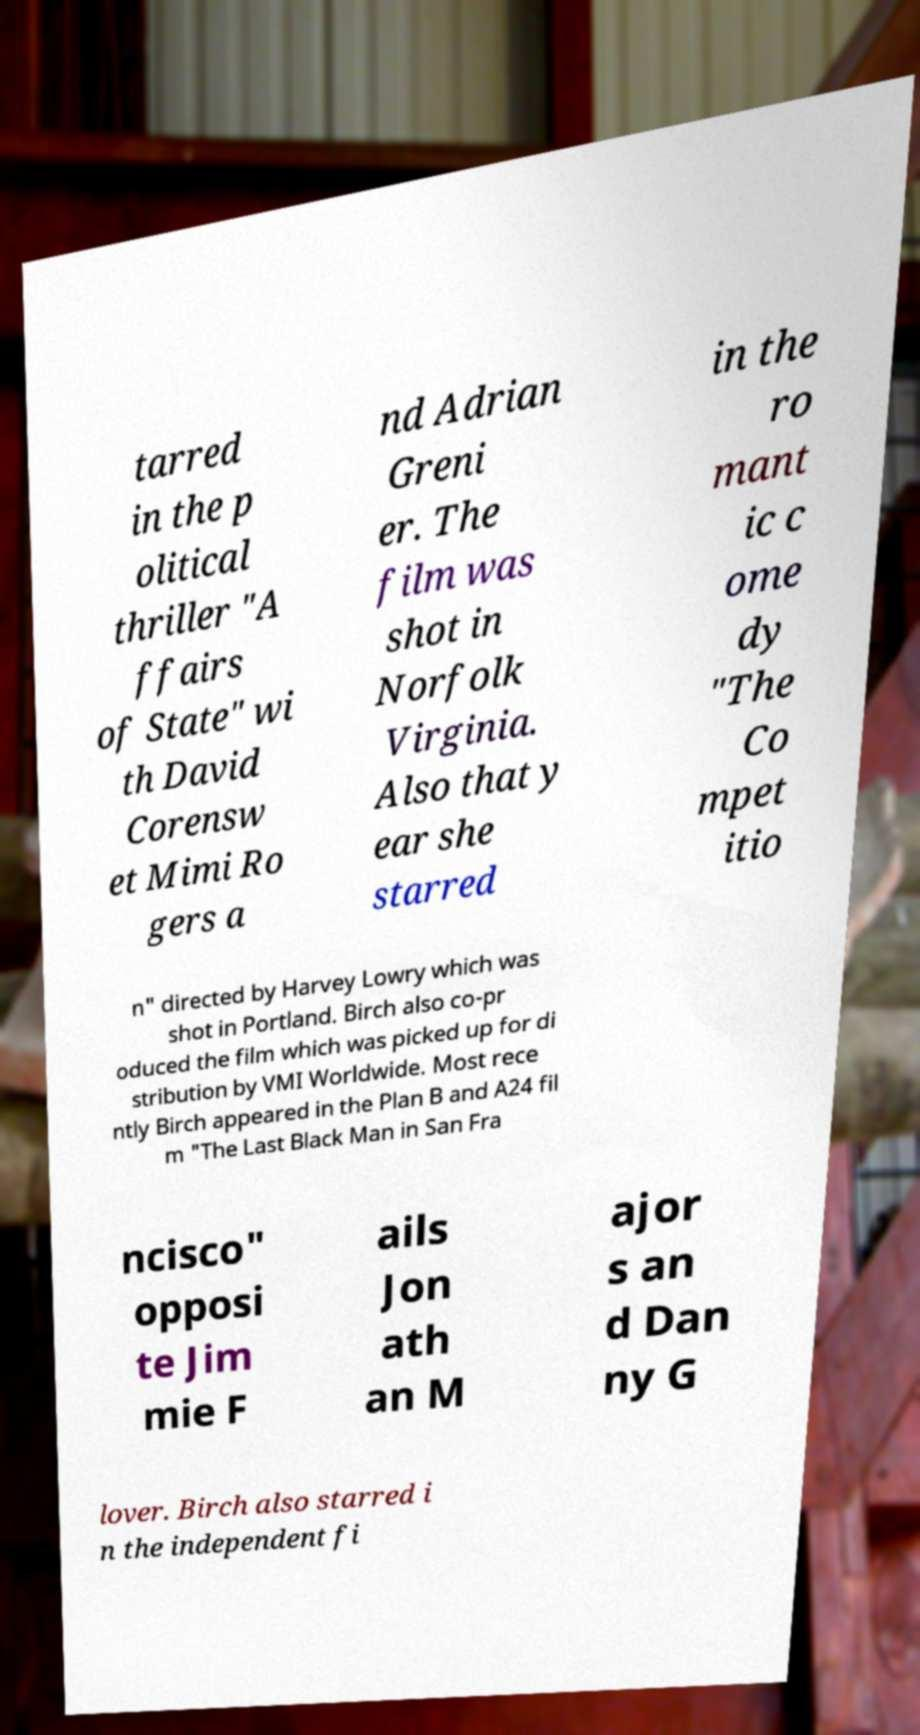There's text embedded in this image that I need extracted. Can you transcribe it verbatim? tarred in the p olitical thriller "A ffairs of State" wi th David Corensw et Mimi Ro gers a nd Adrian Greni er. The film was shot in Norfolk Virginia. Also that y ear she starred in the ro mant ic c ome dy "The Co mpet itio n" directed by Harvey Lowry which was shot in Portland. Birch also co-pr oduced the film which was picked up for di stribution by VMI Worldwide. Most rece ntly Birch appeared in the Plan B and A24 fil m "The Last Black Man in San Fra ncisco" opposi te Jim mie F ails Jon ath an M ajor s an d Dan ny G lover. Birch also starred i n the independent fi 